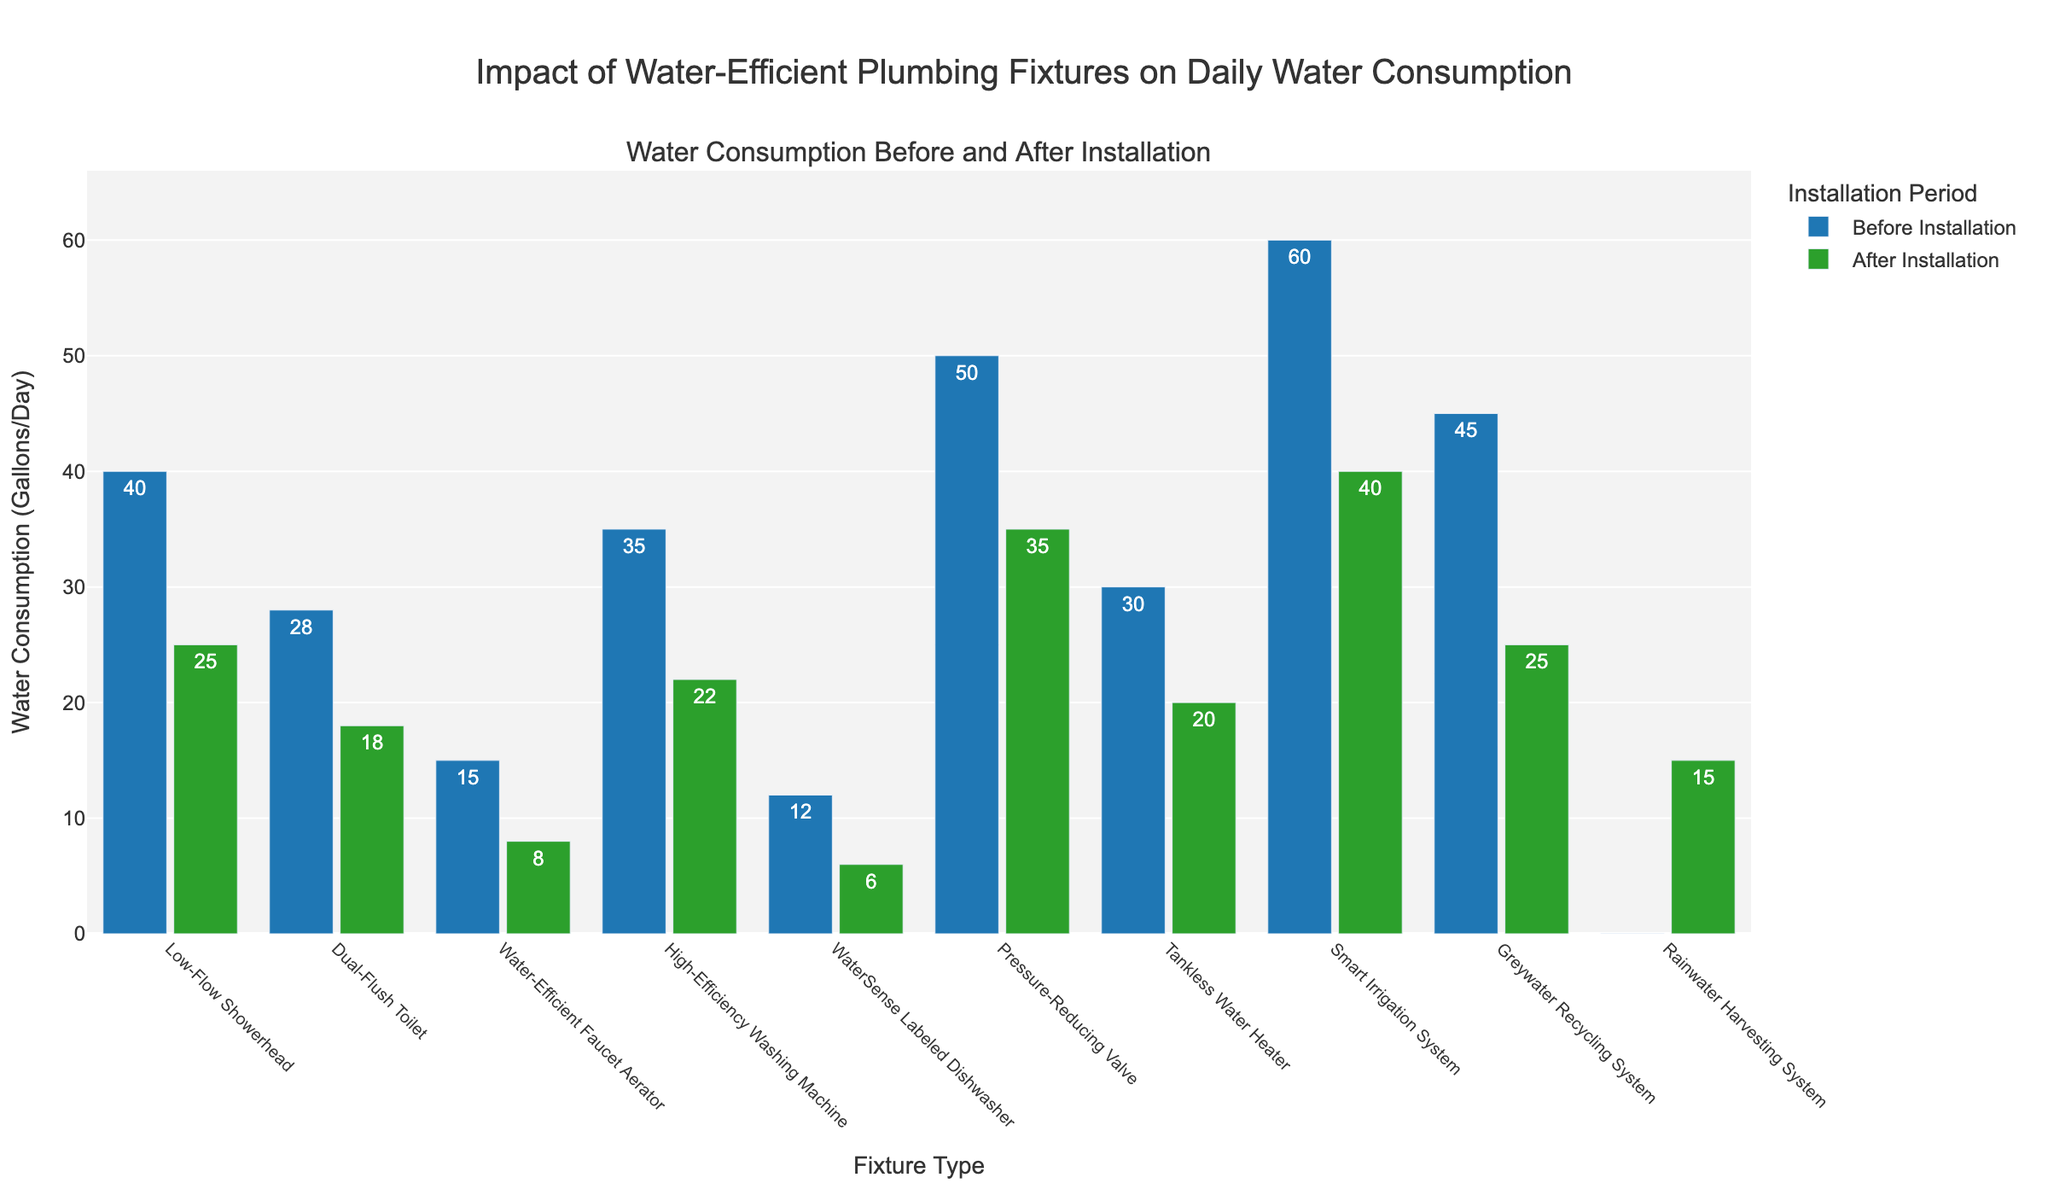How much did the water consumption reduce for the Low-Flow Showerhead after installation? The bar for the Low-Flow Showerhead shows the values 40 (before) and 25 (after). The reduction is calculated as 40 - 25 = 15 gallons per day.
Answer: 15 gallons/day Which fixture has the greatest reduction in water consumption after installation? To find the greatest reduction, we compare the before and after values for each fixture: Low-Flow Showerhead (15), Dual-Flush Toilet (10), Water-Efficient Faucet Aerator (7), High-Efficiency Washing Machine (13), WaterSense Labeled Dishwasher (6), Pressure-Reducing Valve (15), Tankless Water Heater (10), Smart Irrigation System (20), Greywater Recycling System (20), and Rainwater Harvesting System (-15). The Smart Irrigation System and Greywater Recycling System both have the greatest reduction of 20 gallons per day.
Answer: Smart Irrigation System and Greywater Recycling System What is the average daily water consumption before installation across all fixtures? Sum the 'Before Installation' values for all fixtures (40 + 28 + 15 + 35 + 12 + 50 + 30 + 60 + 45 + 0 = 315). Divide by the number of fixtures (10) to get the average: 315 / 10 = 31.5 gallons per day.
Answer: 31.5 gallons/day Which fixture shows an increase in water consumption after installation and by how much? Comparing the before and after values, the Rainwater Harvesting System shows an increase from 0 to 15 gallons per day. The increase is 15 gallons/day.
Answer: Rainwater Harvesting System, 15 gallons/day By how much did the water consumption reduce on average for all fixtures after installation? First, calculate the reduction for each fixture: (15 for Low-Flow Showerhead, 10 for Dual-Flush Toilet, 7 for Water-Efficient Faucet Aerator, 13 for High-Efficiency Washing Machine, 6 for WaterSense Labeled Dishwasher, 15 for Pressure-Reducing Valve, 10 for Tankless Water Heater, 20 for Smart Irrigation System, 20 for Greywater Recycling System, and -15 for Rainwater Harvesting System). Sum these reductions: (15 + 10 + 7 + 13 + 6 + 15 + 10 + 20 + 20 - 15 = 101). Divide by the number of fixtures (10) to get the average: 101 / 10 = 10.1 gallons per day.
Answer: 10.1 gallons/day Which fixture type(s) consumed the same amount of water both before and after installation of water-efficient plumbing fixtures? Analyze the visual properties of the bars: None show equal lengths before and after installation.
Answer: None Which fixture shows the largest absolute reduction visually on the chart and how is it represented? The largest absolute reduction can be visually confirmed with the highest difference in bar lengths. The Smart Irrigation System and Greywater Recycling System bars show the largest difference, representing a reduction of 20 gallons per day.
Answer: Smart Irrigation System and Greywater Recycling System, 20 gallons/day What is the longest green bar representing 'After Installation' values in the chart? The tallest green bar represents the highest 'After Installation' value. Scanning the green bars, the tallest one is the Smart Irrigation System at 40 gallons per day.
Answer: Smart Irrigation System, 40 gallons/day Which fixture type had the highest daily water consumption before installation? Examine the 'Before Installation' blue bars. The tallest blue bar corresponds to the Smart Irrigation System with 60 gallons per day.
Answer: Smart Irrigation System, 60 gallons/day Which color represents the water consumption before installation in the chart? Understanding the chart's legend and visual cues, the water consumption before installation is represented with blue bars.
Answer: Blue 